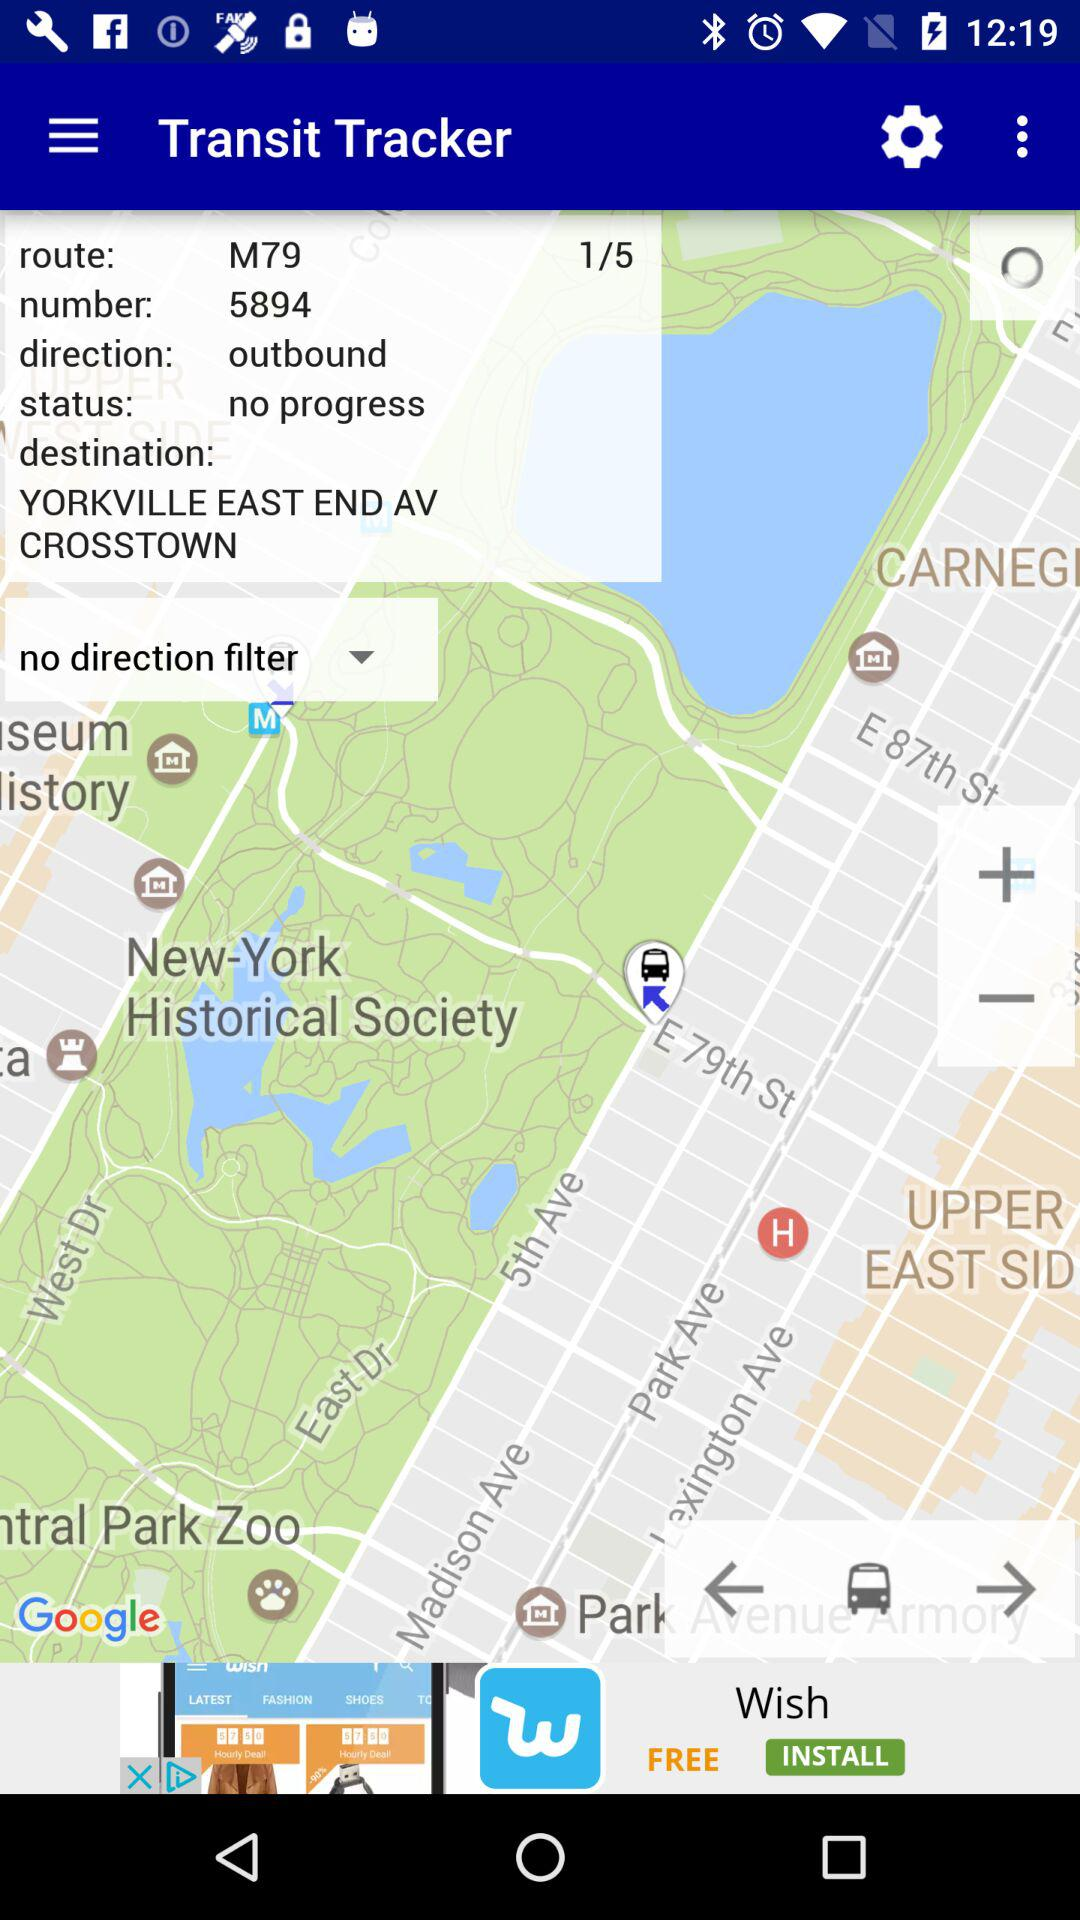What is the status? The status is "no progress". 